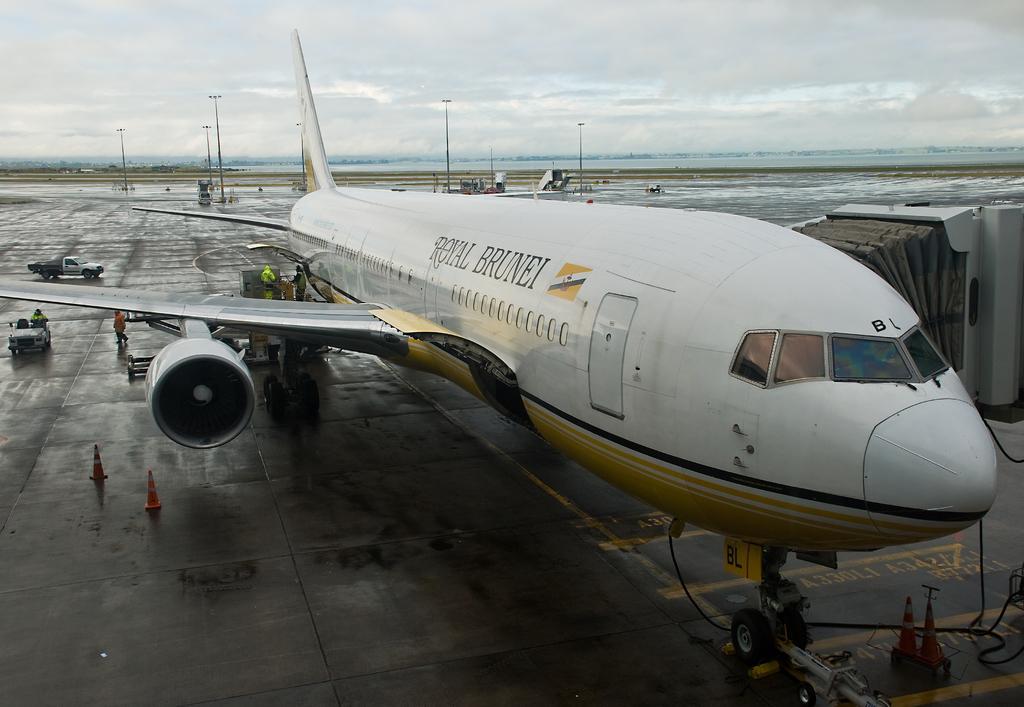Could you give a brief overview of what you see in this image? In this image we can see an airplane and there is some text on it and we can see few people. There are few vehicles and we can see some other objects on the ground and there are some light poles and at the top we can see the sky. 